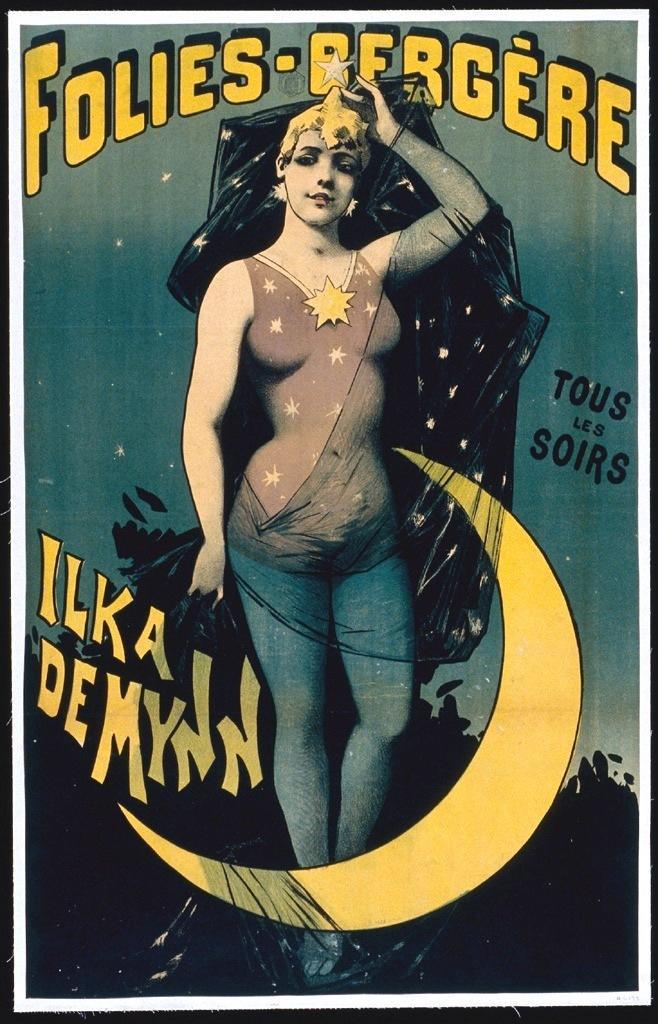Could you give a brief overview of what you see in this image? This is a poster having texts and paintings of a woman, sky and other objects. 